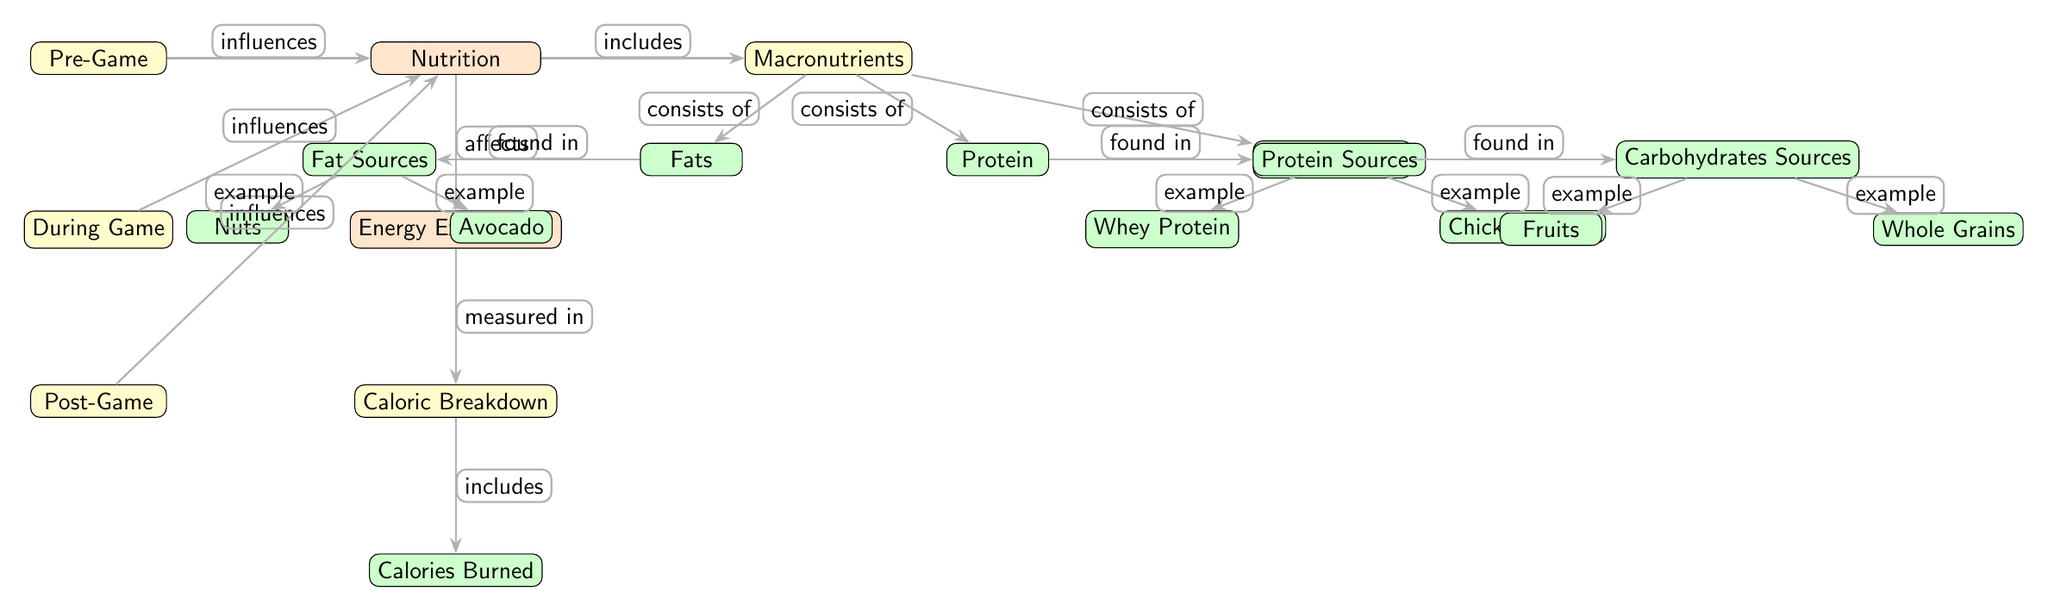What are the three main macronutrients shown in the diagram? The diagram clearly lists three main macronutrients: Protein, Carbohydrates, and Fats. These are categorized under the 'Macronutrients' node which is connected to 'Nutrition.'
Answer: Protein, Carbohydrates, Fats How does 'Nutrition' influence 'Energy Expenditure'? The diagram indicates that 'Nutrition' affects 'Energy Expenditure' through an edge labeled "affects." This relationship directly connects the two nodes in the diagram.
Answer: Affects What is an example of a protein source listed in the diagram? The diagram lists 'Chicken Breast' and 'Whey Protein' as examples of protein sources connected to the 'Protein Sources' node.
Answer: Chicken Breast What influences 'Nutrition' before the game? According to the diagram, 'Pre-Game' influences 'Nutrition', indicating that factors or actions taken before the game have an impact on nutritional aspects.
Answer: Pre-Game How is energy expenditure quantified in the diagram? The diagram shows that 'Energy Expenditure' is measured in 'Calories,' which is represented as a separate node labeled 'Calories Burned' under 'Caloric Breakdown.'
Answer: Calories What follows 'During Game' in terms of nutrition? Following 'During Game', the next stage listed in the diagram is 'Post-Game,' which indicates that nutritional influence continues after the game.
Answer: Post-Game What elements contribute to the 'Caloric Breakdown'? The 'Caloric Breakdown' in the diagram is associated with the node 'Calories Burned,' indicating that energy expenditure quantified here is a breakdown of the total calories burned during activities.
Answer: Calories Burned Which macronutrient is found in nuts according to the diagram? The diagram specifies that 'Nuts' are categorized under 'Fat Sources,' meaning they are associated with the intake of Fats, which is one of the three main macronutrients.
Answer: Fats 